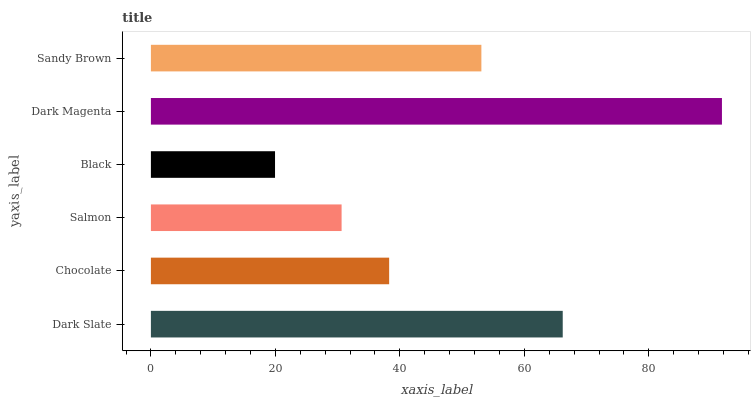Is Black the minimum?
Answer yes or no. Yes. Is Dark Magenta the maximum?
Answer yes or no. Yes. Is Chocolate the minimum?
Answer yes or no. No. Is Chocolate the maximum?
Answer yes or no. No. Is Dark Slate greater than Chocolate?
Answer yes or no. Yes. Is Chocolate less than Dark Slate?
Answer yes or no. Yes. Is Chocolate greater than Dark Slate?
Answer yes or no. No. Is Dark Slate less than Chocolate?
Answer yes or no. No. Is Sandy Brown the high median?
Answer yes or no. Yes. Is Chocolate the low median?
Answer yes or no. Yes. Is Chocolate the high median?
Answer yes or no. No. Is Sandy Brown the low median?
Answer yes or no. No. 